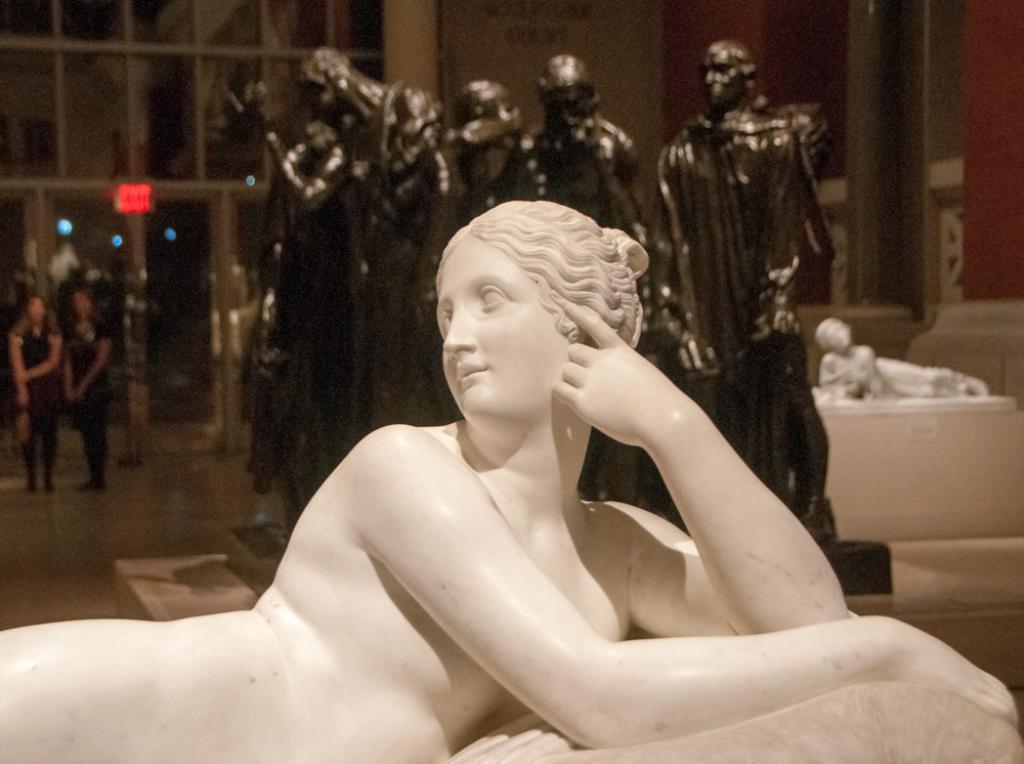Can you describe this image briefly? In this image there are a few sculptures and two people inside the building, there is a sign board attached to the glass door. 